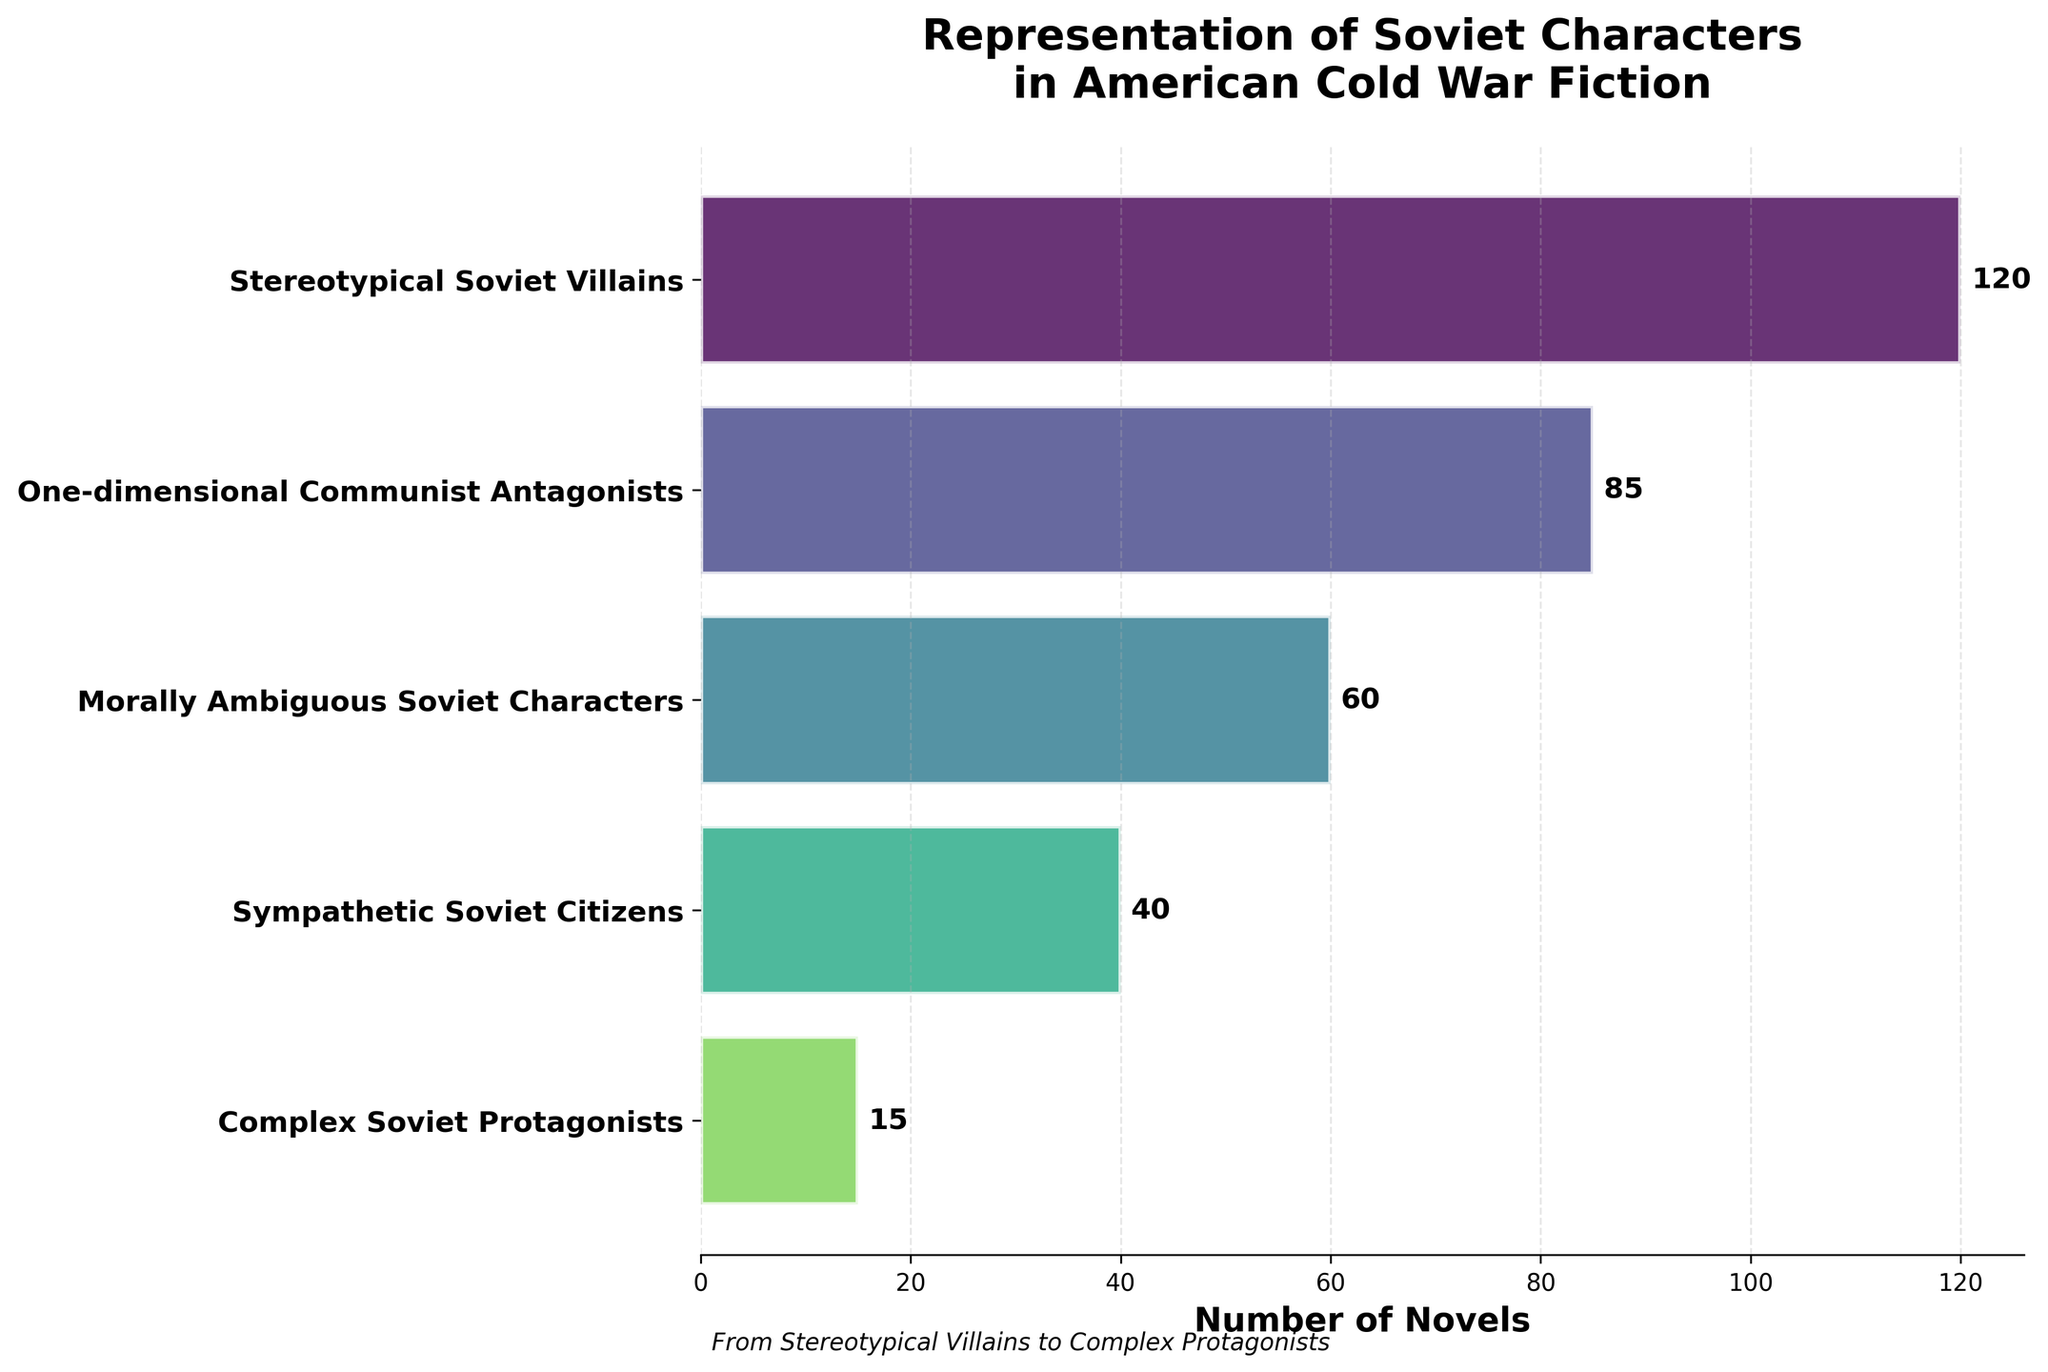what is the title of the figure? The title of the figure is located at the top and serves as a summary of what the chart is about. In this case, it reads "Representation of Soviet Characters in American Cold War Fiction."
Answer: Representation of Soviet Characters in American Cold War Fiction how many stages are represented in the funnel chart? The figure includes a number of discrete stages, each depicted as a separate bar. Counting these stages reveals a total of five different categories.
Answer: 5 which stage has the highest number of novels? By observing the lengths of the bars, the longest bar represents "Stereotypical Soviet Villains," indicating it has the highest count.
Answer: Stereotypical Soviet Villains how does the number of novels portraying "Sympathetic Soviet Citizens" compare to "Complex Soviet Protagonists"? Compare the lengths of the corresponding bars; "Sympathetic Soviet Citizens" has a higher count (40) than "Complex Soviet Protagonists" (15).
Answer: Sympathetic Soviet Citizens what is the difference between the number of novels with "One-dimensional Communist Antagonists" and "Morally Ambiguous Soviet Characters"? Subtract the count of "Morally Ambiguous Soviet Characters" (60) from "One-dimensional Communist Antagonists" (85).
Answer: 25 which stage represents the least number of novels? The shortest bar corresponds to "Complex Soviet Protagonists," with a value of 15 novels.
Answer: Complex Soviet Protagonists what is the total number of novels across all stages? Add up the novel counts for all five categories: 120 (Stereotypical Soviet Villains) + 85 (One-dimensional Communist Antagonists) + 60 (Morally Ambiguous Soviet Characters) + 40 (Sympathetic Soviet Citizens) + 15 (Complex Soviet Protagonists) = 320.
Answer: 320 how does the portrayal of "Morally Ambiguous Soviet Characters" compare to "Stereotypical Soviet Villains" in terms of the number of novels? The bar for "Stereotypical Soviet Villains" is significantly longer, indicating there are 120 novels versus 60 novels for "Morally Ambiguous Soviet Characters."
Answer: Stereotypical Soviet Villains if you combine the novels from the stages "Sympathetic Soviet Citizens" and "Complex Soviet Protagonists," how many novels do you get? Add the numbers from both stages: 40 (Sympathetic Soviet Citizens) + 15 (Complex Soviet Protagonists).
Answer: 55 what trend can you observe as the portrayal of Soviet characters becomes more nuanced? The lengths of the bars decrease progressively from stereotypical to more complex portrayals, indicating fewer novels for nuanced characters.
Answer: Decreasing trend 